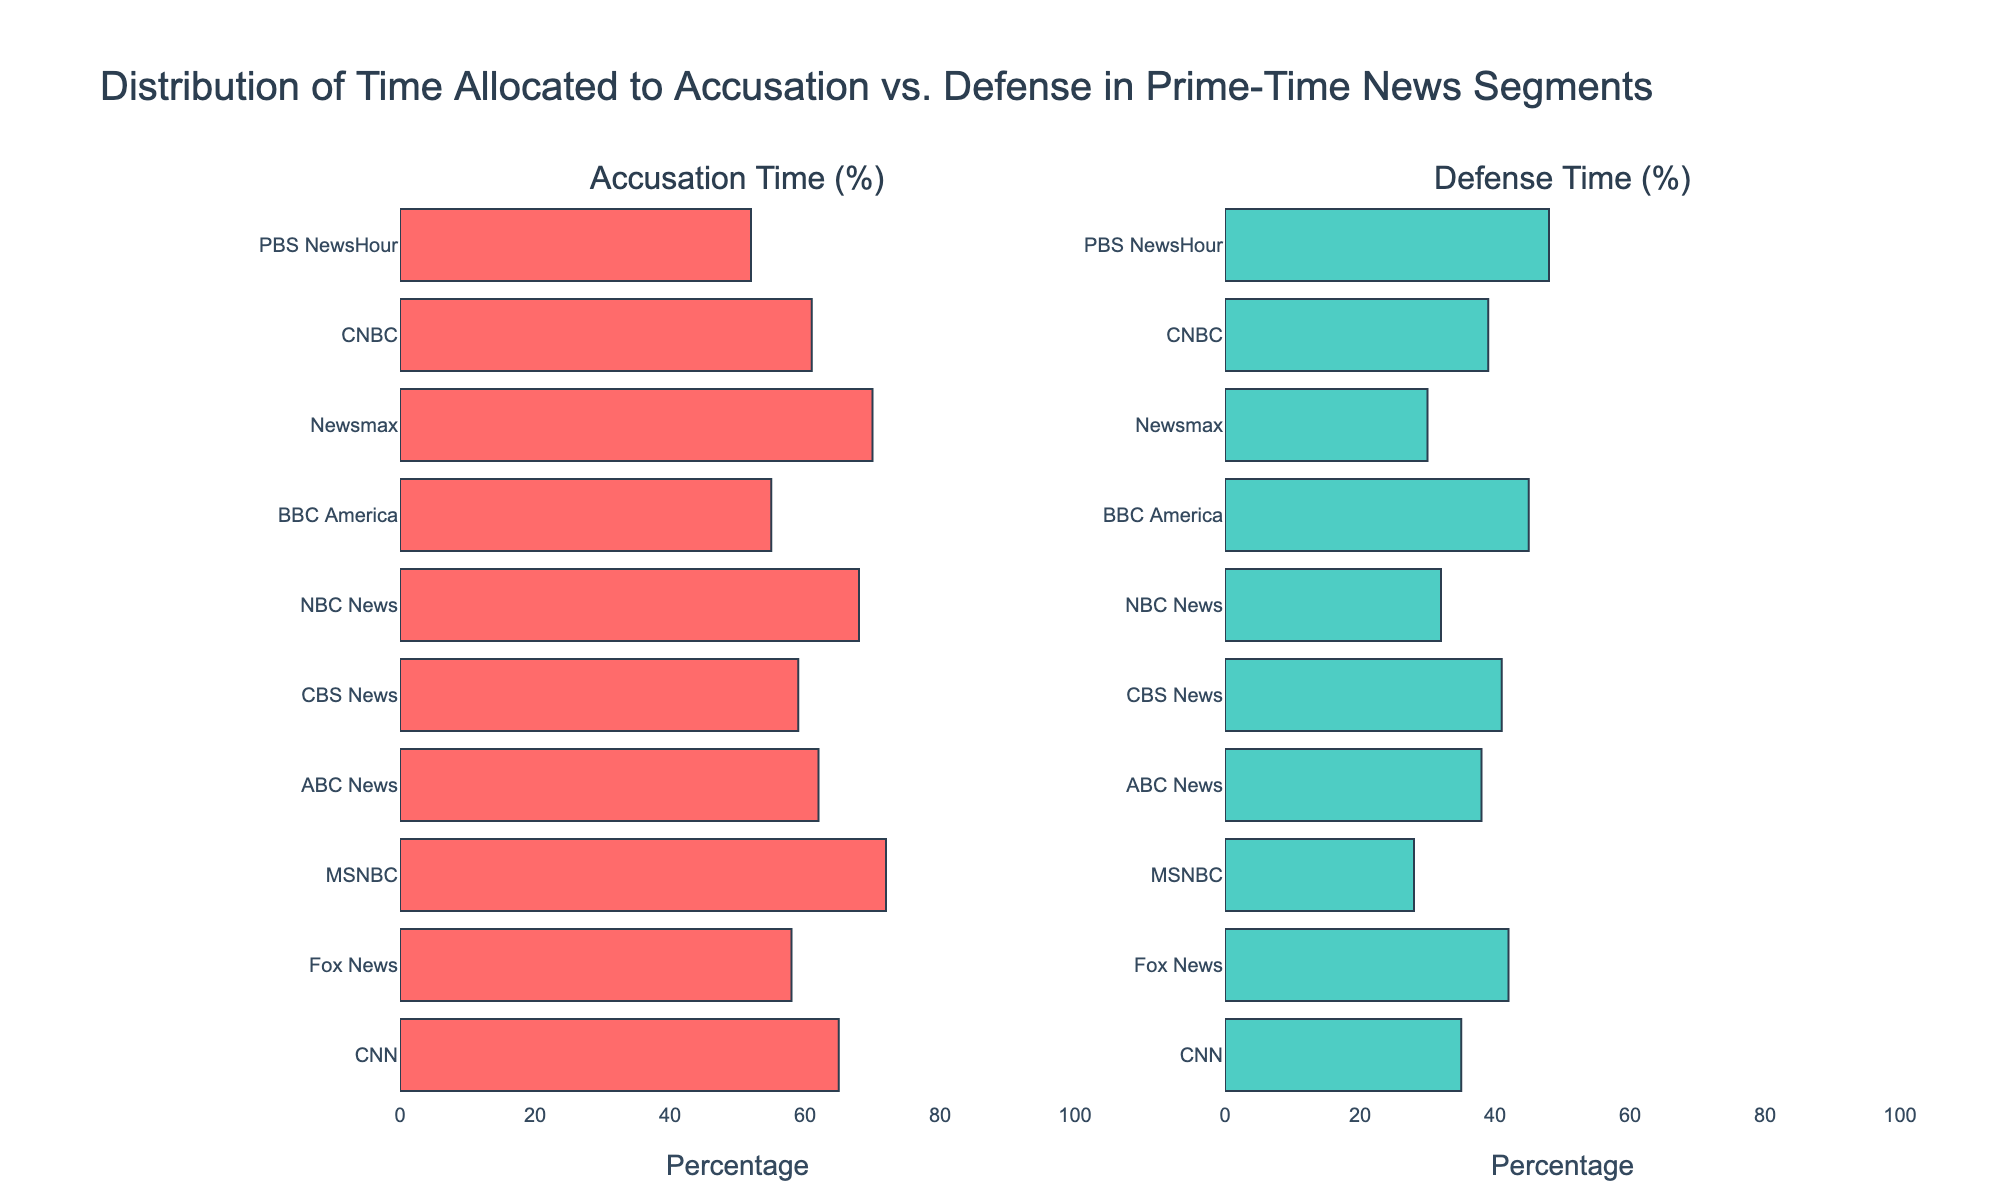What's the title of the figure? The title of the figure is usually at the top and large in size. The given code specifies the title text.
Answer: Distribution of Time Allocated to Accusation vs. Defense in Prime-Time News Segments Which network has the highest percentage of time allocated to accusation? Look at the horizontal bar representing the accusation time. The longest bar indicates the highest percentage.
Answer: MSNBC Which network allocates the least time to defense? Observe the defense time horizontal bars. The shortest bar corresponds to the least percentage of time.
Answer: MSNBC What is the average percentage of time allocated to defense across all networks? Sum the defense times of all networks and divide by the number of networks. (35+42+28+38+41+32+45+30+39+48)/10 = 37.8
Answer: 37.8 Is there a network that dedicates more time to defense than to accusation? Check if any network's defense percentage is greater than its accusation percentage.
Answer: No What is the difference in accusation time between CNN and Fox News? Subtract the accusation time of Fox News from CNN (65 - 58).
Answer: 7 Which network shows the closest balance between accusation and defense times? Look for the network with the smallest difference between accusation and defense times: PBS NewsHour (52-48=4).
Answer: PBS NewsHour Which network has the second highest percentage of defense time? First find the highest (PBS NewsHour) then identify the second highest (BBC America).
Answer: BBC America How much larger is the accusation time of ABC News compared to CBS News? Subtract CBS News' accusation time from ABC News' (62 - 59).
Answer: 3 What is the range of accusation times across all networks? Identify the maximum and minimum percentages of accusation (max = MSNBC 72%, min = PBS NewsHour 52%) and calculate the difference (72 - 52).
Answer: 20 Compare the accusation time between CNBC and NBC News. Which one is larger and by how much? Subtract CNBC’s percentage from NBC News' (68 - 61).
Answer: 7 